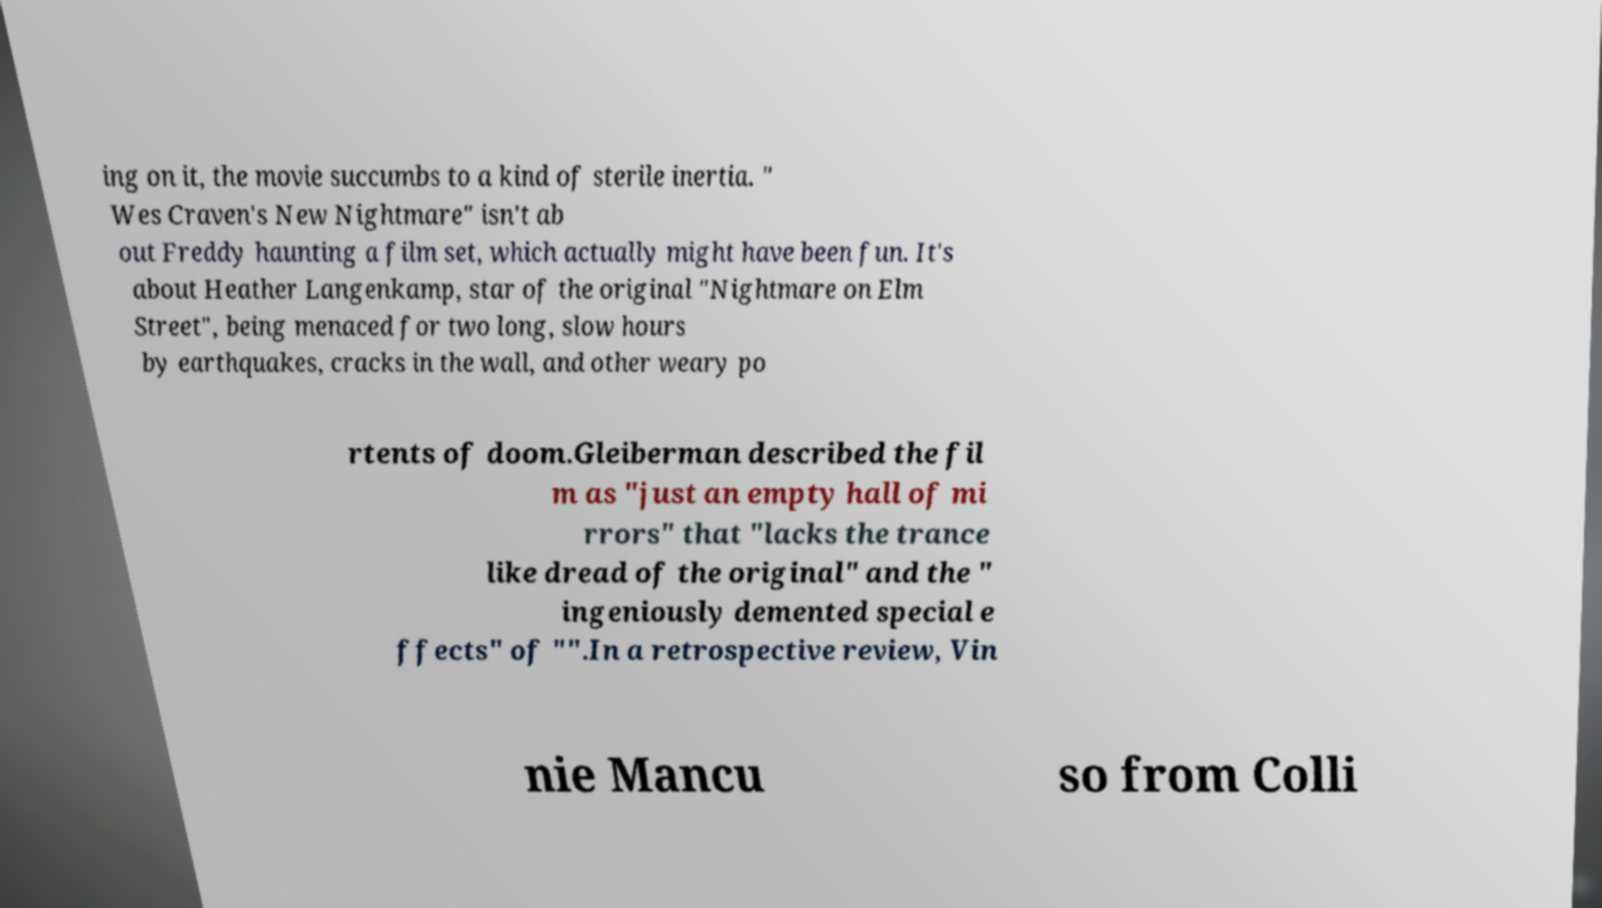For documentation purposes, I need the text within this image transcribed. Could you provide that? ing on it, the movie succumbs to a kind of sterile inertia. " Wes Craven's New Nightmare" isn't ab out Freddy haunting a film set, which actually might have been fun. It's about Heather Langenkamp, star of the original "Nightmare on Elm Street", being menaced for two long, slow hours by earthquakes, cracks in the wall, and other weary po rtents of doom.Gleiberman described the fil m as "just an empty hall of mi rrors" that "lacks the trance like dread of the original" and the " ingeniously demented special e ffects" of "".In a retrospective review, Vin nie Mancu so from Colli 